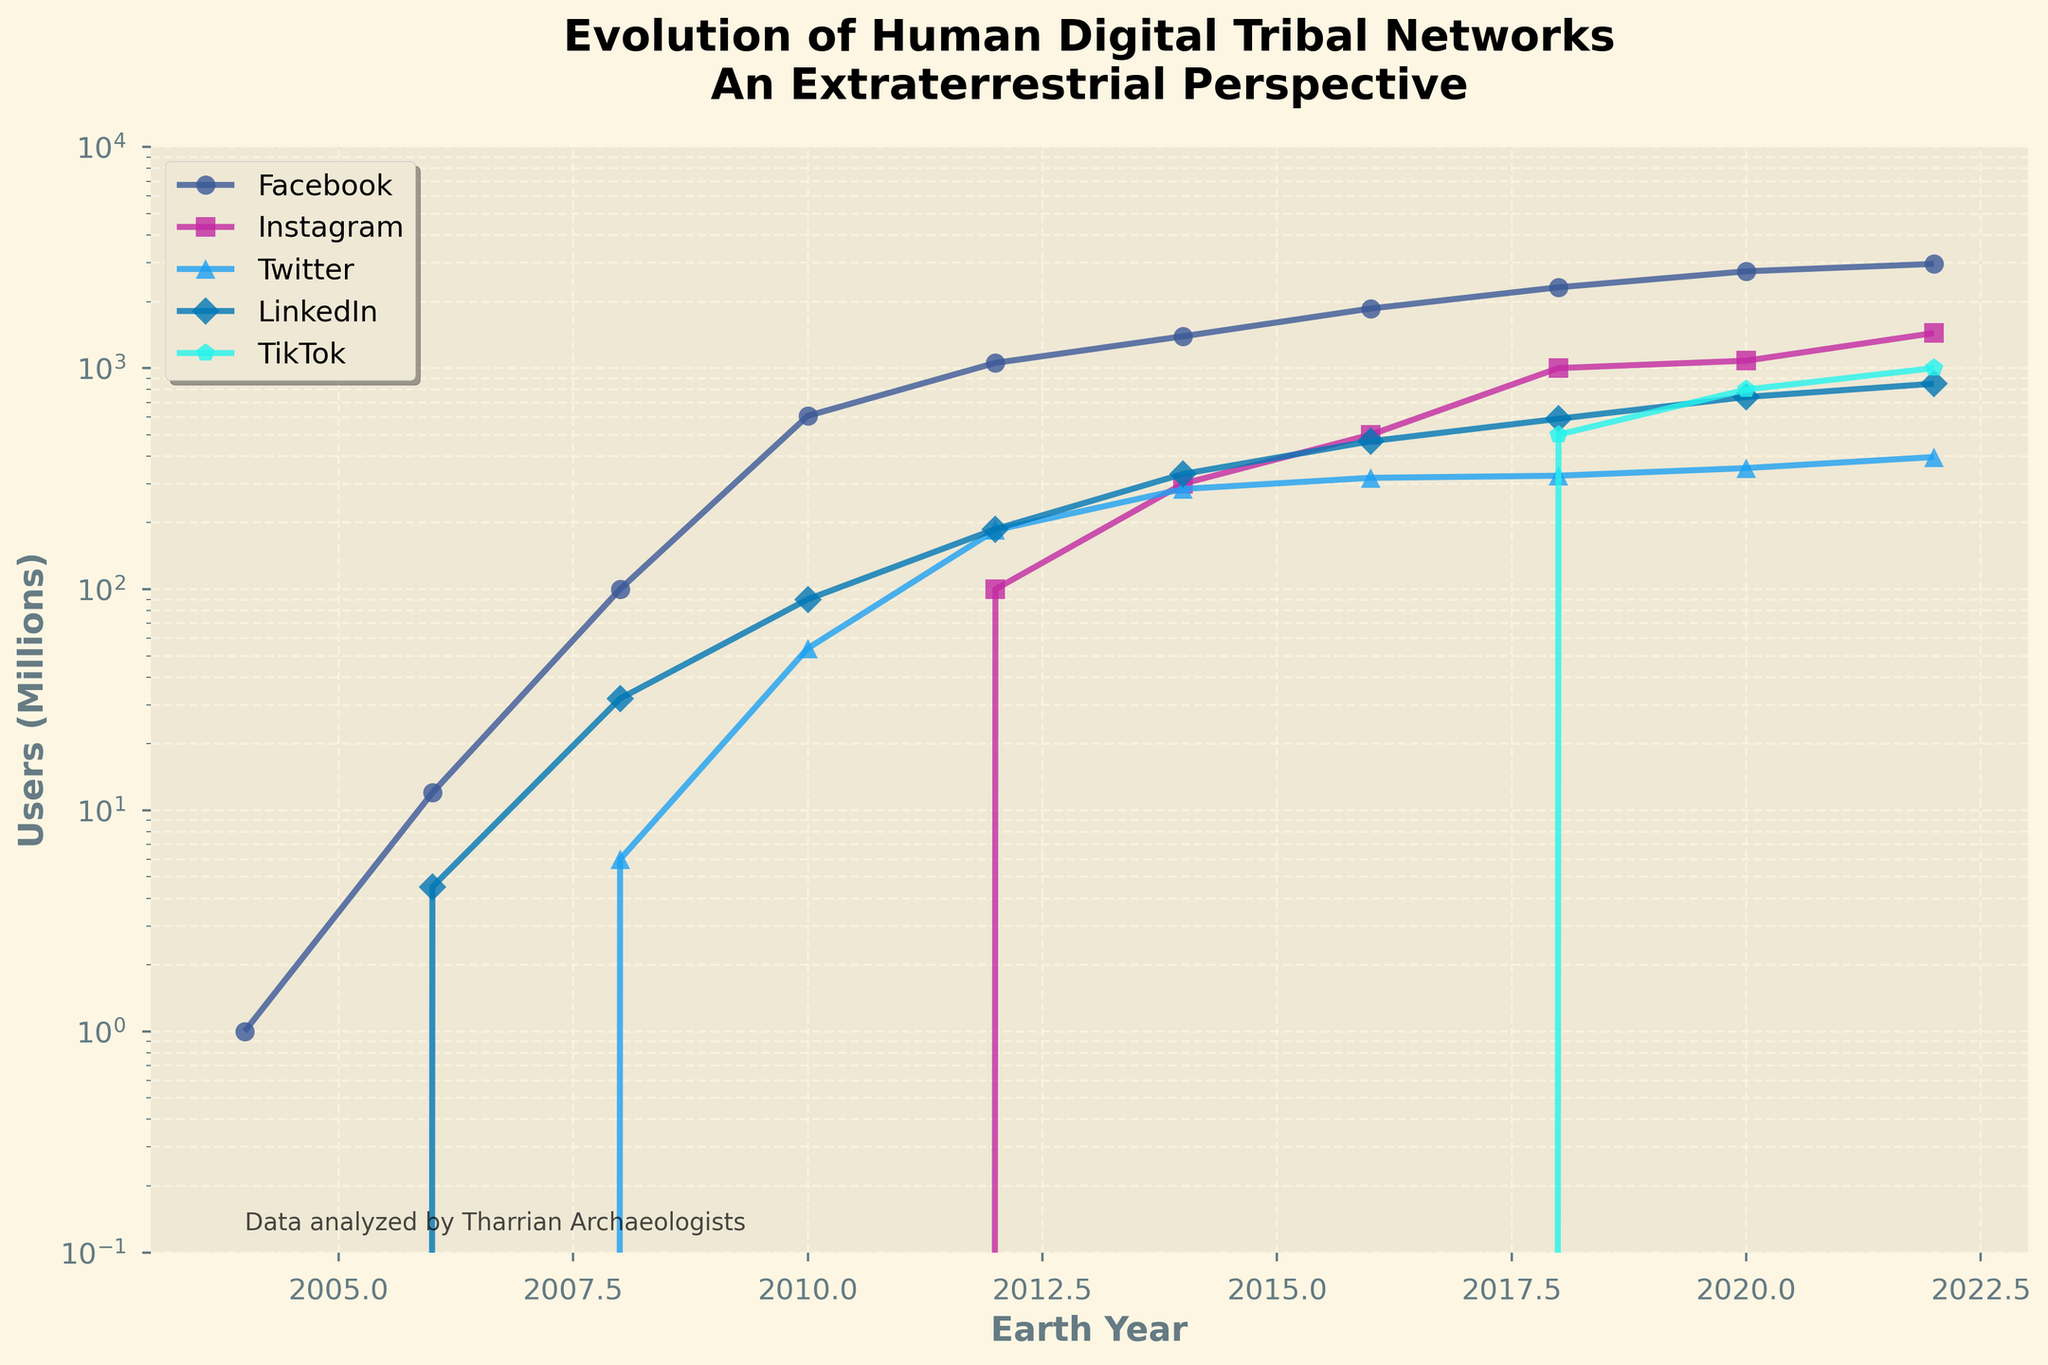What year did TikTok first appear in the chart? TikTok first appears in the chart when there is a non-zero value for its users. This is in the year 2018.
Answer: 2018 Which platform had the highest number of users in 2020? By looking at the end of each line corresponding to the year 2020, Facebook has the highest peak among all the platforms, indicating it had the most users.
Answer: Facebook Compare the growth of Instagram and LinkedIn users between 2016 and 2020. Which one grew more? From 2016 to 2020, Instagram grew from 500 million to 1080 million users, a difference of 580 million. LinkedIn grew from 467 million to 740 million users, a difference of 273 million. Therefore, Instagram grew more.
Answer: Instagram Which two social media platforms showed a log-linear growth pattern? Log-linear growth can be identified by relatively straight lines on a log-scale plot. Facebook and LinkedIn both show relatively straight lines over the years, indicating log-linear growth.
Answer: Facebook and LinkedIn What is the average number of TikTok users between 2018 and 2022? The number of TikTok users in 2018, 2020, and 2022 are 500 million, 800 million, and 1000 million respectively. The average is calculated as (500 + 800 + 1000) / 3 = 2300 / 3 ≈ 767 million.
Answer: Approx. 767 million Which year did Instagram surpass the 1 billion user mark? By observing the Instagram line on the graph, it passes the 1 billion (1000 million) users mark between 2018 and 2020. The specific value in the table shows that in 2018, Instagram reached 1 billion users.
Answer: 2018 In which year did Twitter have its peak number of users according to the chart? The peak of the Twitter line on the chart is observed in 2022, where users reached 396 million.
Answer: 2022 How many years after its inception did Facebook reach 1 billion users? Facebook started with 1 million users in 2004 and reached approximately 1 billion users in 2012, which is 8 years later.
Answer: 8 years By what factor did the number of LinkedIn users increase from 2008 to 2022? In 2008, LinkedIn had 32 million users. In 2022, it had 850 million users. The factor increase is calculated as 850 million / 32 million = 26.56.
Answer: 26.56 Which platform had the smallest user base in 2008? By observing the chart and corresponding values in 2008, Instagram and TikTok have 0 users since they hadn't launched yet. Among the platforms with data, Twitter had the smallest user base with 6 million.
Answer: Twitter 